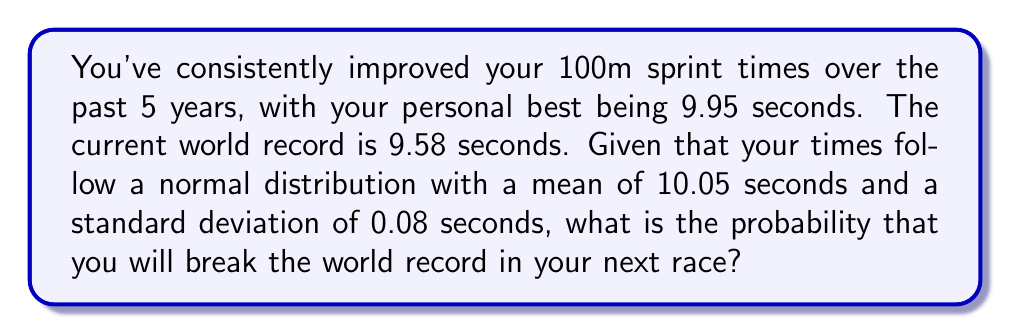Solve this math problem. To solve this problem, we need to use the properties of the normal distribution and calculate the z-score for the world record time. Then, we can find the probability of achieving a time better than the world record.

Step 1: Identify the given information
- Your times follow a normal distribution
- Mean (μ) = 10.05 seconds
- Standard deviation (σ) = 0.08 seconds
- World record time = 9.58 seconds

Step 2: Calculate the z-score for the world record time
The z-score formula is:
$$ z = \frac{x - \mu}{\sigma} $$

Where x is the world record time, μ is the mean, and σ is the standard deviation.

$$ z = \frac{9.58 - 10.05}{0.08} = -5.875 $$

Step 3: Use the standard normal distribution table or a calculator to find the probability
The probability of breaking the world record is the area to the left of the z-score on the standard normal distribution curve.

Using a standard normal distribution table or calculator, we find:

$$ P(Z < -5.875) \approx 2.1 \times 10^{-9} $$

Step 4: Convert the probability to a percentage
$$ 2.1 \times 10^{-9} \times 100\% \approx 2.1 \times 10^{-7}\% $$

Therefore, the probability of breaking the world record in your next race is approximately 0.00000021%.
Answer: $2.1 \times 10^{-7}\%$ 